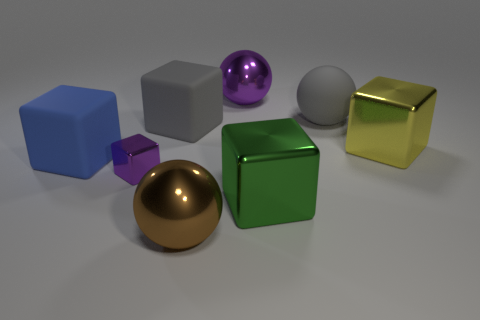The gray object left of the big metal block left of the big yellow shiny cube is made of what material?
Ensure brevity in your answer.  Rubber. There is a blue rubber object; are there any large green things to the left of it?
Keep it short and to the point. No. Is the number of large cubes that are to the right of the big blue block greater than the number of brown shiny spheres?
Your answer should be very brief. Yes. Are there any cubes of the same color as the large matte ball?
Ensure brevity in your answer.  Yes. There is another rubber block that is the same size as the blue rubber block; what is its color?
Your response must be concise. Gray. There is a large purple thing that is behind the brown shiny object; is there a matte cube on the right side of it?
Provide a succinct answer. No. There is a block right of the green thing; what is it made of?
Ensure brevity in your answer.  Metal. Are the big block that is on the right side of the green block and the big cube on the left side of the tiny cube made of the same material?
Give a very brief answer. No. Are there an equal number of large things to the right of the green thing and purple things that are left of the blue object?
Give a very brief answer. No. How many large gray things have the same material as the small block?
Keep it short and to the point. 0. 